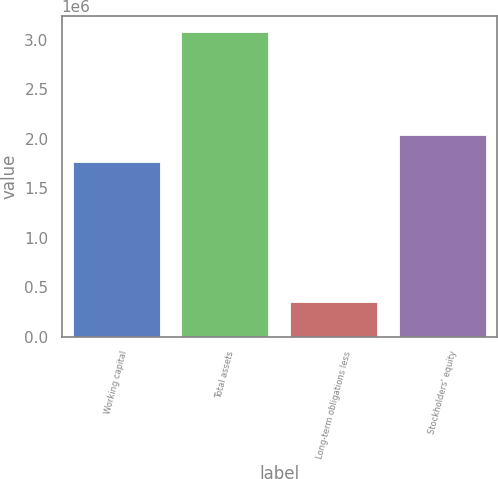Convert chart to OTSL. <chart><loc_0><loc_0><loc_500><loc_500><bar_chart><fcel>Working capital<fcel>Total assets<fcel>Long-term obligations less<fcel>Stockholders' equity<nl><fcel>1.76799e+06<fcel>3.08378e+06<fcel>355050<fcel>2.04086e+06<nl></chart> 